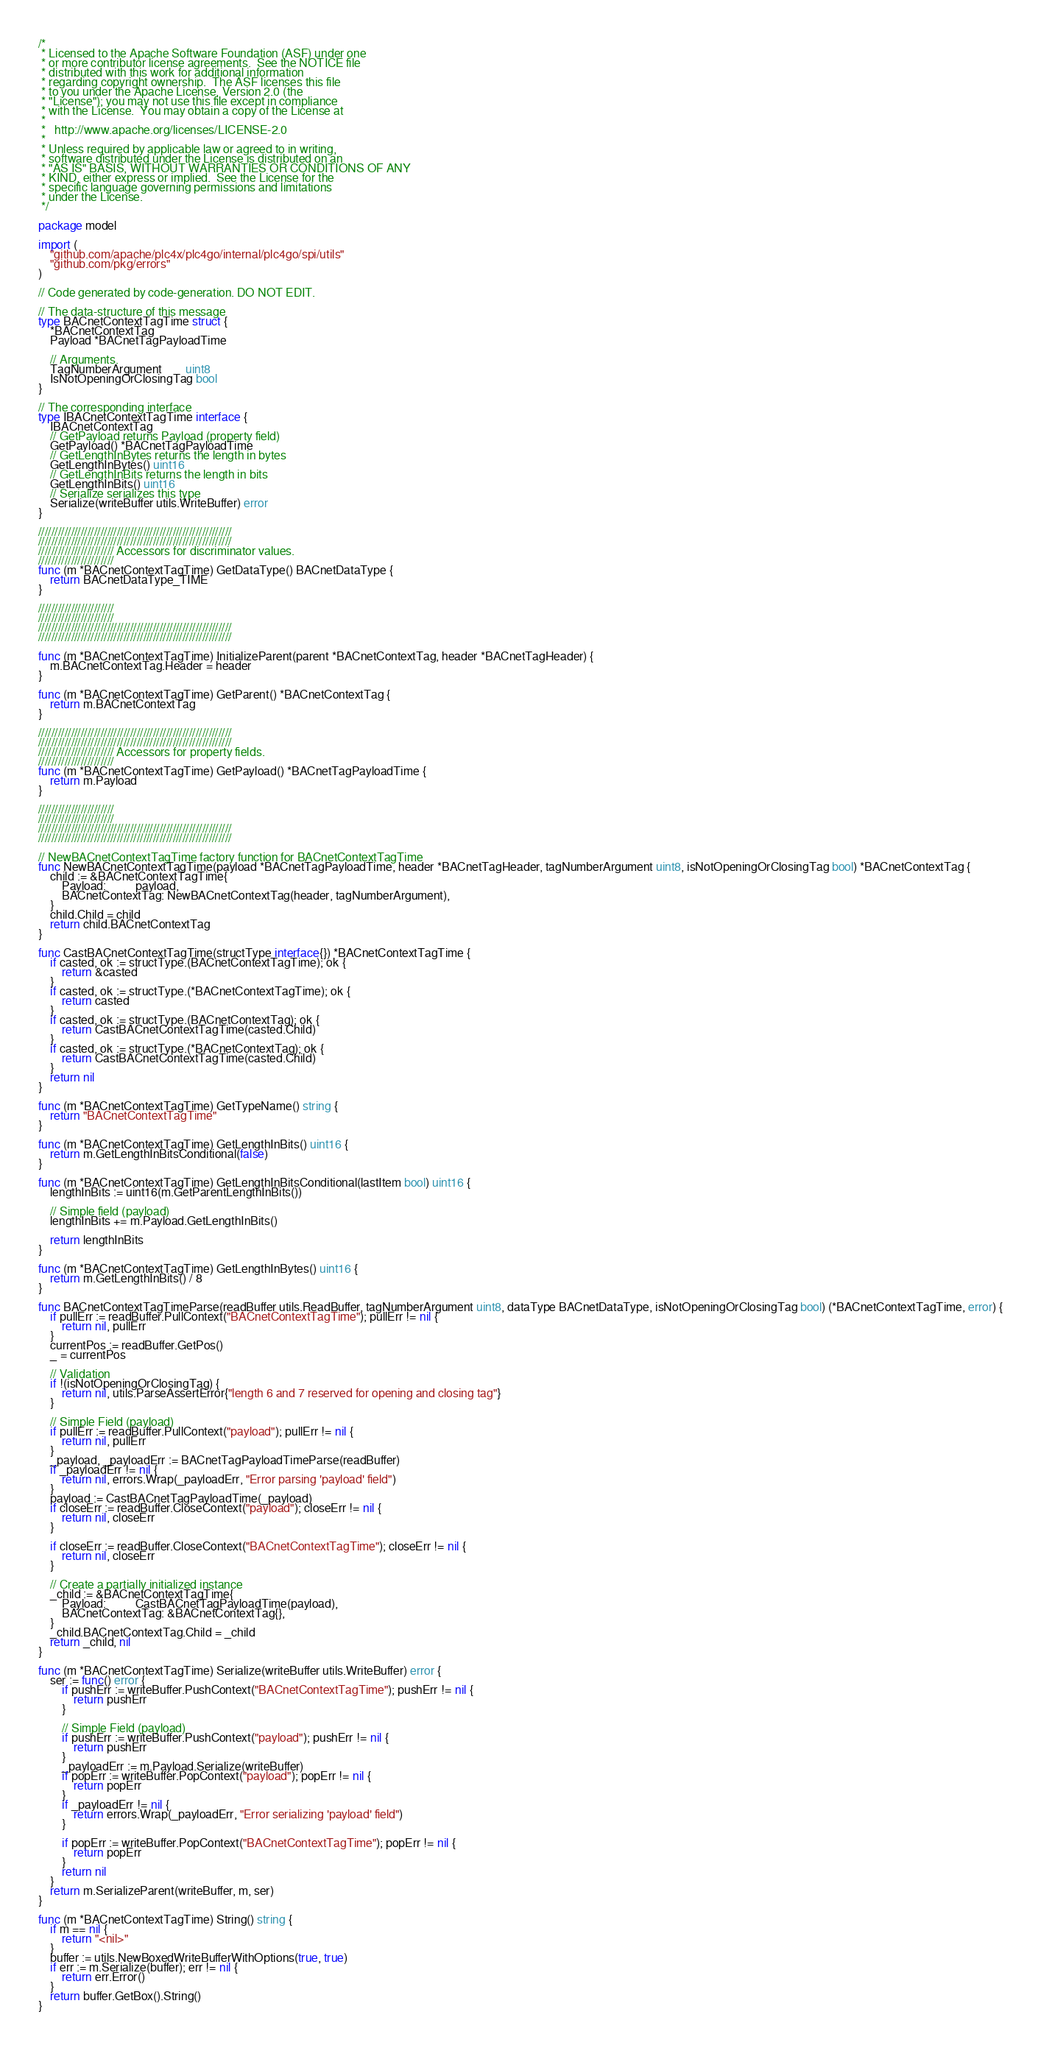<code> <loc_0><loc_0><loc_500><loc_500><_Go_>/*
 * Licensed to the Apache Software Foundation (ASF) under one
 * or more contributor license agreements.  See the NOTICE file
 * distributed with this work for additional information
 * regarding copyright ownership.  The ASF licenses this file
 * to you under the Apache License, Version 2.0 (the
 * "License"); you may not use this file except in compliance
 * with the License.  You may obtain a copy of the License at
 *
 *   http://www.apache.org/licenses/LICENSE-2.0
 *
 * Unless required by applicable law or agreed to in writing,
 * software distributed under the License is distributed on an
 * "AS IS" BASIS, WITHOUT WARRANTIES OR CONDITIONS OF ANY
 * KIND, either express or implied.  See the License for the
 * specific language governing permissions and limitations
 * under the License.
 */

package model

import (
	"github.com/apache/plc4x/plc4go/internal/plc4go/spi/utils"
	"github.com/pkg/errors"
)

// Code generated by code-generation. DO NOT EDIT.

// The data-structure of this message
type BACnetContextTagTime struct {
	*BACnetContextTag
	Payload *BACnetTagPayloadTime

	// Arguments.
	TagNumberArgument        uint8
	IsNotOpeningOrClosingTag bool
}

// The corresponding interface
type IBACnetContextTagTime interface {
	IBACnetContextTag
	// GetPayload returns Payload (property field)
	GetPayload() *BACnetTagPayloadTime
	// GetLengthInBytes returns the length in bytes
	GetLengthInBytes() uint16
	// GetLengthInBits returns the length in bits
	GetLengthInBits() uint16
	// Serialize serializes this type
	Serialize(writeBuffer utils.WriteBuffer) error
}

///////////////////////////////////////////////////////////
///////////////////////////////////////////////////////////
/////////////////////// Accessors for discriminator values.
///////////////////////
func (m *BACnetContextTagTime) GetDataType() BACnetDataType {
	return BACnetDataType_TIME
}

///////////////////////
///////////////////////
///////////////////////////////////////////////////////////
///////////////////////////////////////////////////////////

func (m *BACnetContextTagTime) InitializeParent(parent *BACnetContextTag, header *BACnetTagHeader) {
	m.BACnetContextTag.Header = header
}

func (m *BACnetContextTagTime) GetParent() *BACnetContextTag {
	return m.BACnetContextTag
}

///////////////////////////////////////////////////////////
///////////////////////////////////////////////////////////
/////////////////////// Accessors for property fields.
///////////////////////
func (m *BACnetContextTagTime) GetPayload() *BACnetTagPayloadTime {
	return m.Payload
}

///////////////////////
///////////////////////
///////////////////////////////////////////////////////////
///////////////////////////////////////////////////////////

// NewBACnetContextTagTime factory function for BACnetContextTagTime
func NewBACnetContextTagTime(payload *BACnetTagPayloadTime, header *BACnetTagHeader, tagNumberArgument uint8, isNotOpeningOrClosingTag bool) *BACnetContextTag {
	child := &BACnetContextTagTime{
		Payload:          payload,
		BACnetContextTag: NewBACnetContextTag(header, tagNumberArgument),
	}
	child.Child = child
	return child.BACnetContextTag
}

func CastBACnetContextTagTime(structType interface{}) *BACnetContextTagTime {
	if casted, ok := structType.(BACnetContextTagTime); ok {
		return &casted
	}
	if casted, ok := structType.(*BACnetContextTagTime); ok {
		return casted
	}
	if casted, ok := structType.(BACnetContextTag); ok {
		return CastBACnetContextTagTime(casted.Child)
	}
	if casted, ok := structType.(*BACnetContextTag); ok {
		return CastBACnetContextTagTime(casted.Child)
	}
	return nil
}

func (m *BACnetContextTagTime) GetTypeName() string {
	return "BACnetContextTagTime"
}

func (m *BACnetContextTagTime) GetLengthInBits() uint16 {
	return m.GetLengthInBitsConditional(false)
}

func (m *BACnetContextTagTime) GetLengthInBitsConditional(lastItem bool) uint16 {
	lengthInBits := uint16(m.GetParentLengthInBits())

	// Simple field (payload)
	lengthInBits += m.Payload.GetLengthInBits()

	return lengthInBits
}

func (m *BACnetContextTagTime) GetLengthInBytes() uint16 {
	return m.GetLengthInBits() / 8
}

func BACnetContextTagTimeParse(readBuffer utils.ReadBuffer, tagNumberArgument uint8, dataType BACnetDataType, isNotOpeningOrClosingTag bool) (*BACnetContextTagTime, error) {
	if pullErr := readBuffer.PullContext("BACnetContextTagTime"); pullErr != nil {
		return nil, pullErr
	}
	currentPos := readBuffer.GetPos()
	_ = currentPos

	// Validation
	if !(isNotOpeningOrClosingTag) {
		return nil, utils.ParseAssertError{"length 6 and 7 reserved for opening and closing tag"}
	}

	// Simple Field (payload)
	if pullErr := readBuffer.PullContext("payload"); pullErr != nil {
		return nil, pullErr
	}
	_payload, _payloadErr := BACnetTagPayloadTimeParse(readBuffer)
	if _payloadErr != nil {
		return nil, errors.Wrap(_payloadErr, "Error parsing 'payload' field")
	}
	payload := CastBACnetTagPayloadTime(_payload)
	if closeErr := readBuffer.CloseContext("payload"); closeErr != nil {
		return nil, closeErr
	}

	if closeErr := readBuffer.CloseContext("BACnetContextTagTime"); closeErr != nil {
		return nil, closeErr
	}

	// Create a partially initialized instance
	_child := &BACnetContextTagTime{
		Payload:          CastBACnetTagPayloadTime(payload),
		BACnetContextTag: &BACnetContextTag{},
	}
	_child.BACnetContextTag.Child = _child
	return _child, nil
}

func (m *BACnetContextTagTime) Serialize(writeBuffer utils.WriteBuffer) error {
	ser := func() error {
		if pushErr := writeBuffer.PushContext("BACnetContextTagTime"); pushErr != nil {
			return pushErr
		}

		// Simple Field (payload)
		if pushErr := writeBuffer.PushContext("payload"); pushErr != nil {
			return pushErr
		}
		_payloadErr := m.Payload.Serialize(writeBuffer)
		if popErr := writeBuffer.PopContext("payload"); popErr != nil {
			return popErr
		}
		if _payloadErr != nil {
			return errors.Wrap(_payloadErr, "Error serializing 'payload' field")
		}

		if popErr := writeBuffer.PopContext("BACnetContextTagTime"); popErr != nil {
			return popErr
		}
		return nil
	}
	return m.SerializeParent(writeBuffer, m, ser)
}

func (m *BACnetContextTagTime) String() string {
	if m == nil {
		return "<nil>"
	}
	buffer := utils.NewBoxedWriteBufferWithOptions(true, true)
	if err := m.Serialize(buffer); err != nil {
		return err.Error()
	}
	return buffer.GetBox().String()
}
</code> 